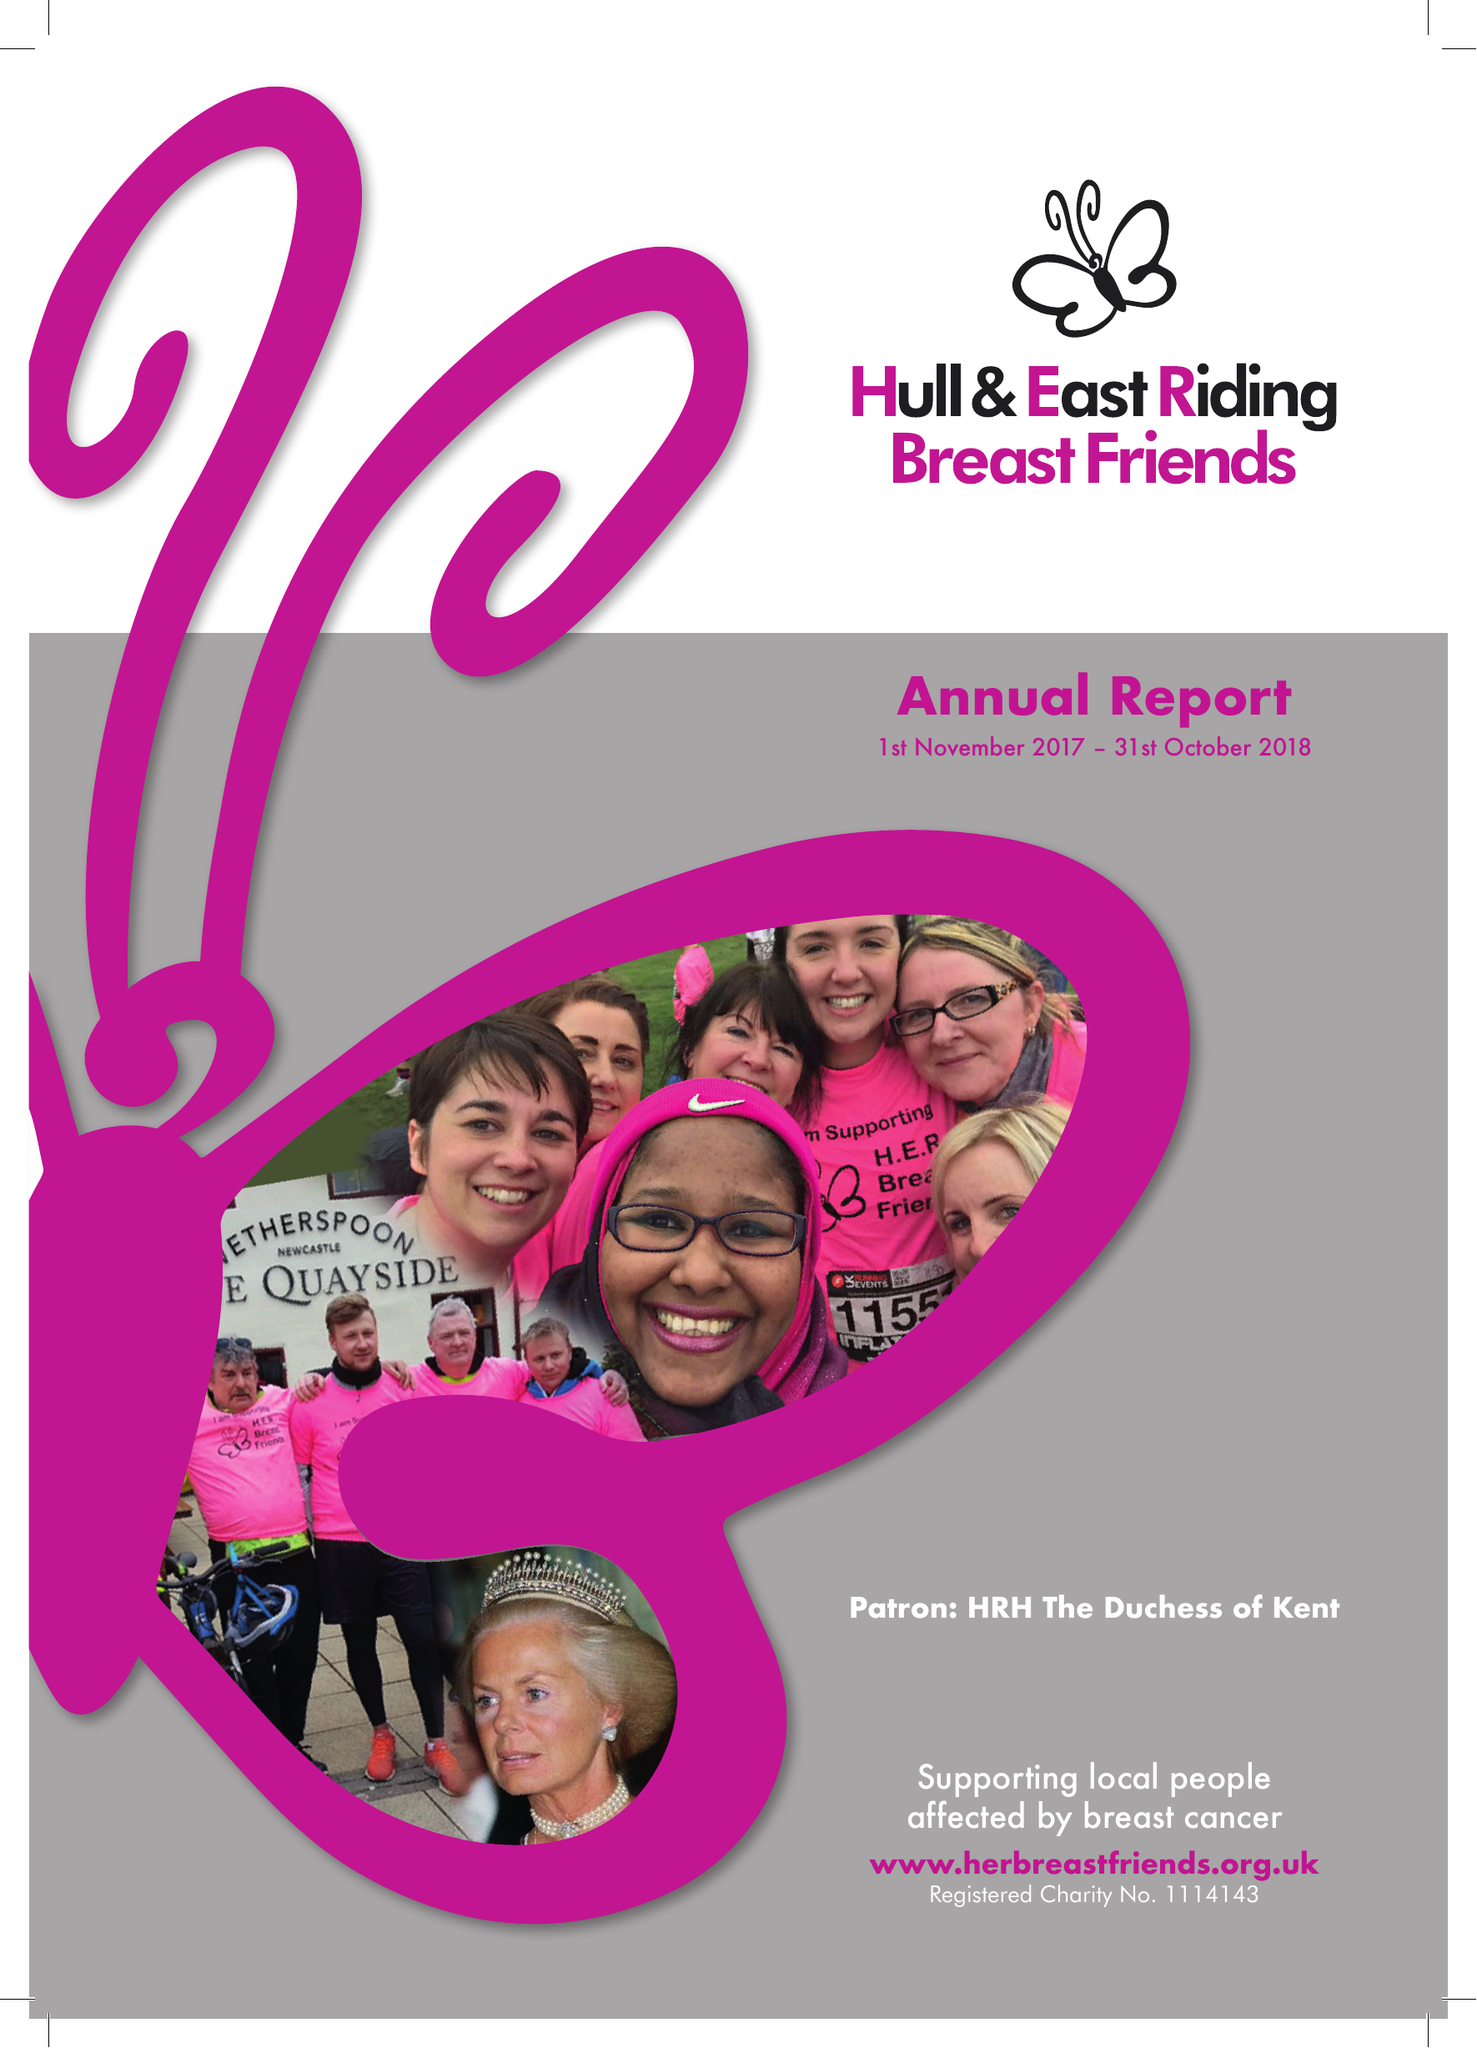What is the value for the report_date?
Answer the question using a single word or phrase. 2018-10-31 